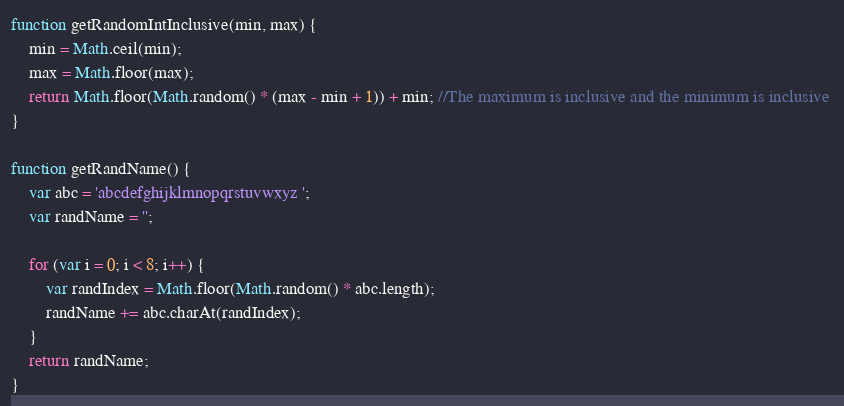Convert code to text. <code><loc_0><loc_0><loc_500><loc_500><_JavaScript_>
function getRandomIntInclusive(min, max) {
    min = Math.ceil(min);
    max = Math.floor(max);
    return Math.floor(Math.random() * (max - min + 1)) + min; //The maximum is inclusive and the minimum is inclusive 
}

function getRandName() {
    var abc = 'abcdefghijklmnopqrstuvwxyz ';
    var randName = '';

    for (var i = 0; i < 8; i++) {
        var randIndex = Math.floor(Math.random() * abc.length);
        randName += abc.charAt(randIndex);
    }
    return randName;
}</code> 